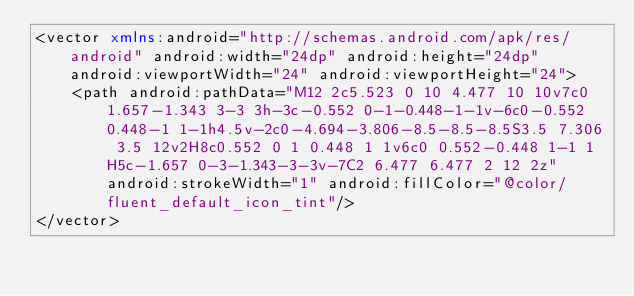Convert code to text. <code><loc_0><loc_0><loc_500><loc_500><_XML_><vector xmlns:android="http://schemas.android.com/apk/res/android" android:width="24dp" android:height="24dp" android:viewportWidth="24" android:viewportHeight="24">
    <path android:pathData="M12 2c5.523 0 10 4.477 10 10v7c0 1.657-1.343 3-3 3h-3c-0.552 0-1-0.448-1-1v-6c0-0.552 0.448-1 1-1h4.5v-2c0-4.694-3.806-8.5-8.5-8.5S3.5 7.306 3.5 12v2H8c0.552 0 1 0.448 1 1v6c0 0.552-0.448 1-1 1H5c-1.657 0-3-1.343-3-3v-7C2 6.477 6.477 2 12 2z" android:strokeWidth="1" android:fillColor="@color/fluent_default_icon_tint"/>
</vector>
</code> 